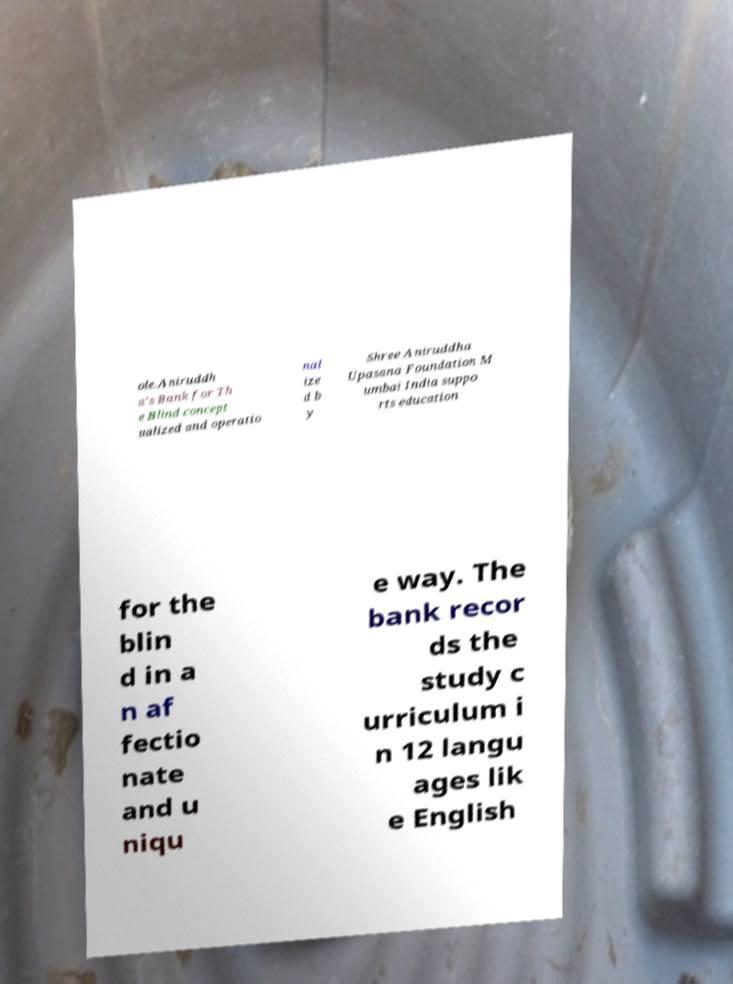There's text embedded in this image that I need extracted. Can you transcribe it verbatim? ole.Aniruddh a's Bank for Th e Blind concept ualized and operatio nal ize d b y Shree Aniruddha Upasana Foundation M umbai India suppo rts education for the blin d in a n af fectio nate and u niqu e way. The bank recor ds the study c urriculum i n 12 langu ages lik e English 